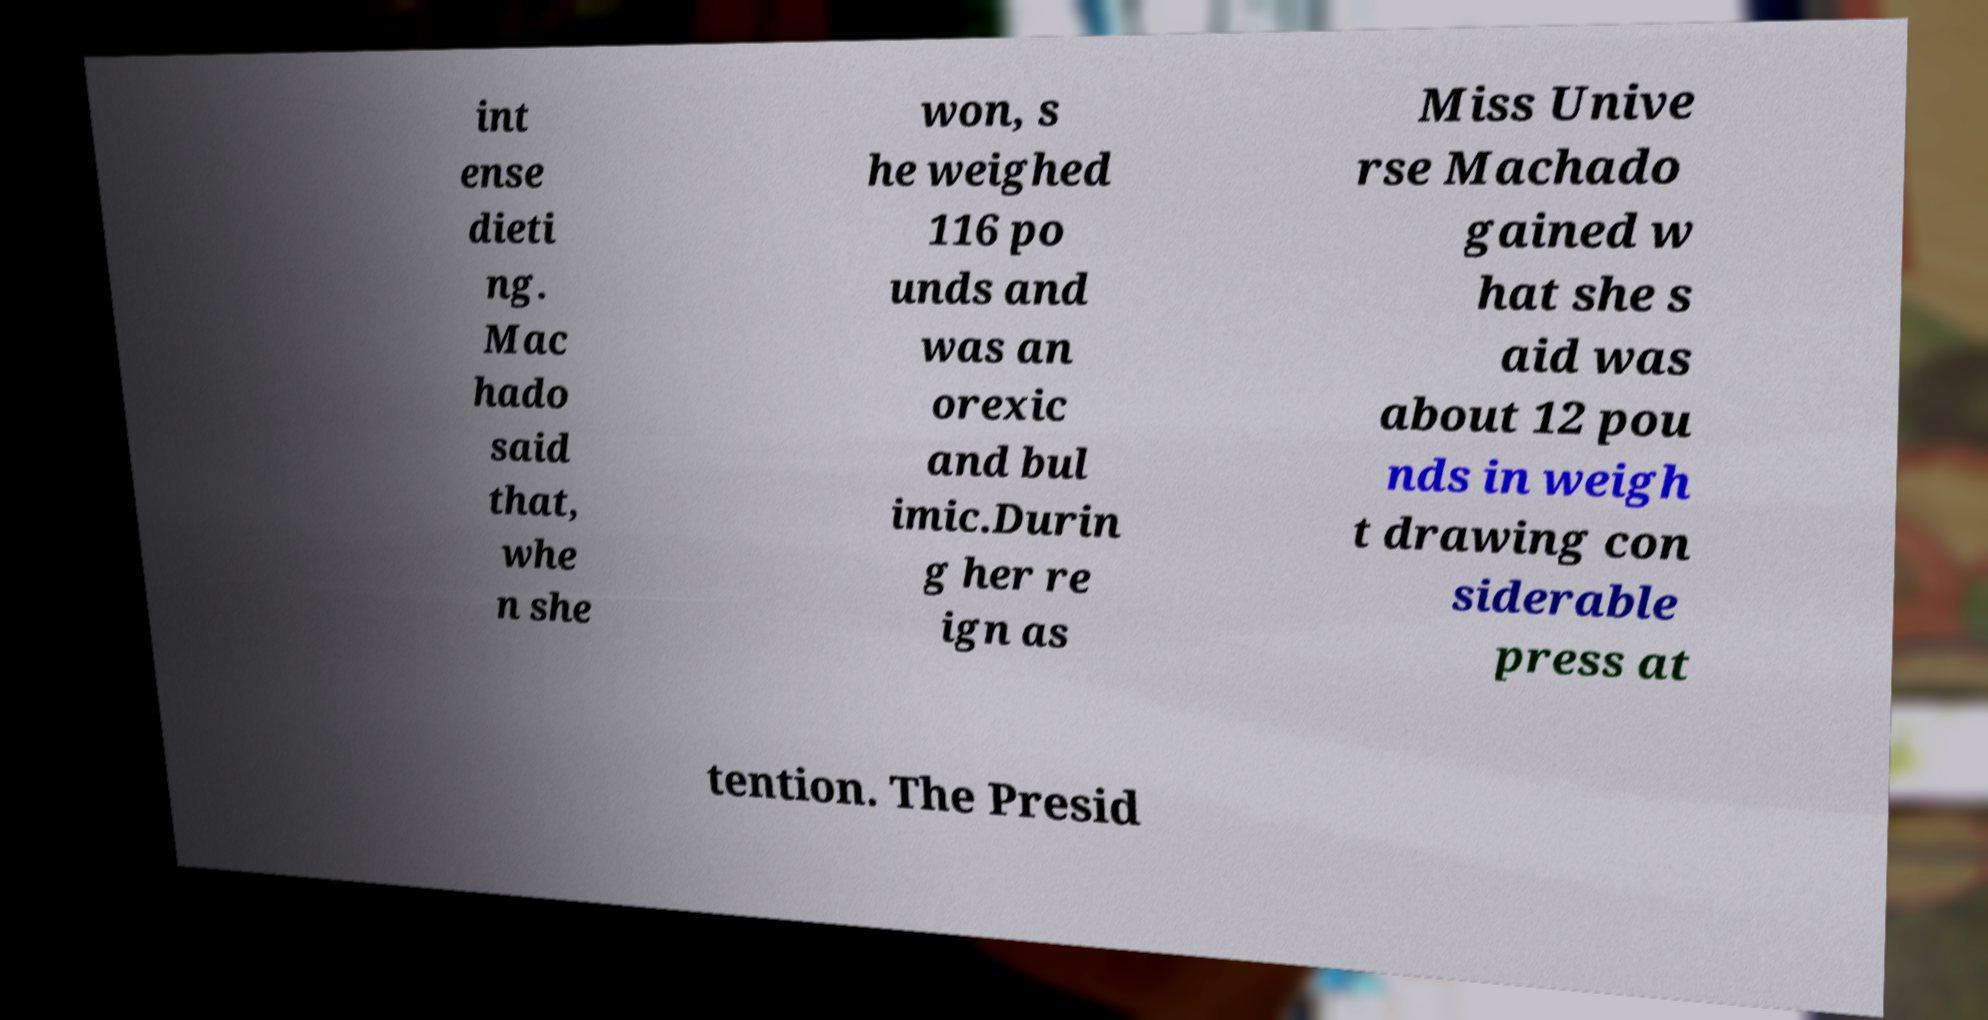I need the written content from this picture converted into text. Can you do that? int ense dieti ng. Mac hado said that, whe n she won, s he weighed 116 po unds and was an orexic and bul imic.Durin g her re ign as Miss Unive rse Machado gained w hat she s aid was about 12 pou nds in weigh t drawing con siderable press at tention. The Presid 